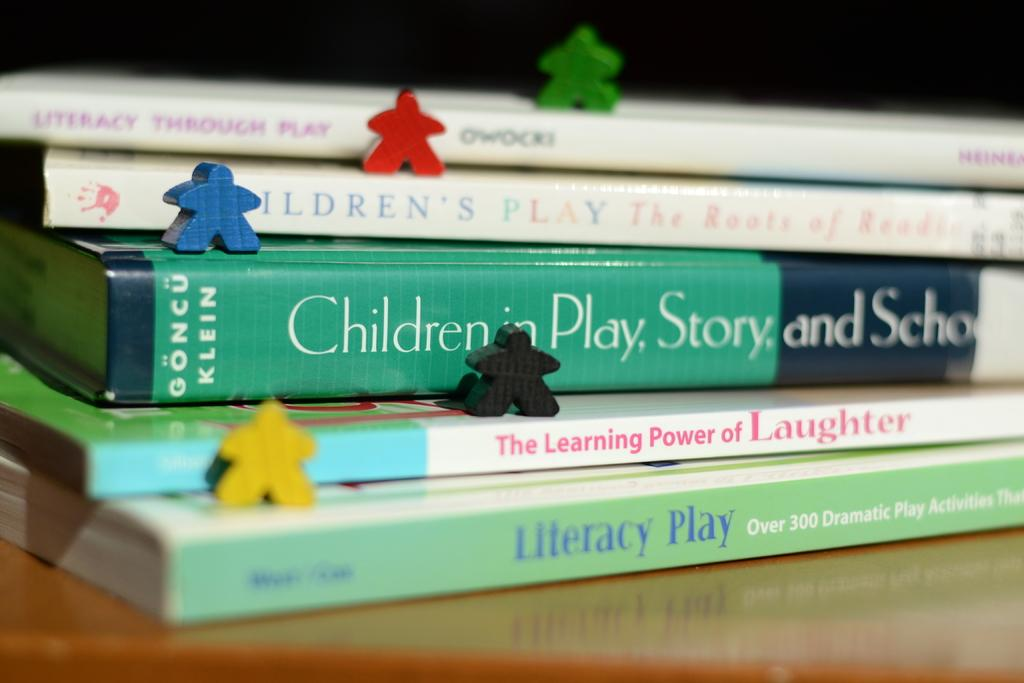<image>
Present a compact description of the photo's key features. a stack of books with one titled 'literacy play' 